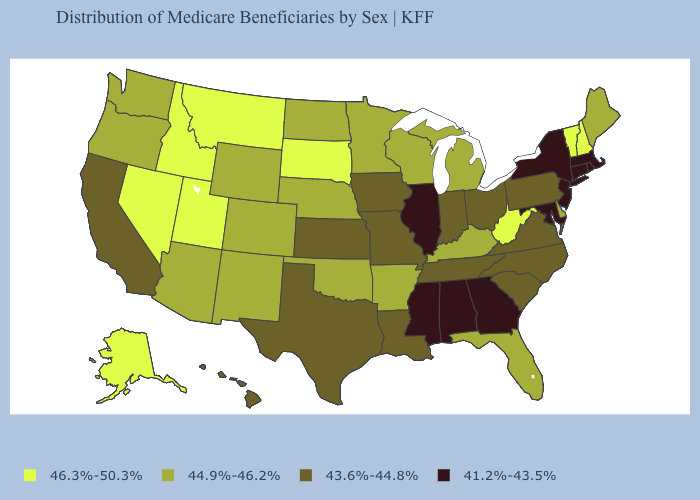What is the value of Iowa?
Write a very short answer. 43.6%-44.8%. Among the states that border Utah , which have the highest value?
Be succinct. Idaho, Nevada. What is the value of South Carolina?
Keep it brief. 43.6%-44.8%. Does Iowa have the same value as Hawaii?
Short answer required. Yes. Does Alabama have the highest value in the South?
Short answer required. No. What is the lowest value in the Northeast?
Keep it brief. 41.2%-43.5%. Name the states that have a value in the range 41.2%-43.5%?
Answer briefly. Alabama, Connecticut, Georgia, Illinois, Maryland, Massachusetts, Mississippi, New Jersey, New York, Rhode Island. Does Nevada have a higher value than Montana?
Be succinct. No. Does Virginia have a lower value than New Mexico?
Answer briefly. Yes. What is the value of Wisconsin?
Answer briefly. 44.9%-46.2%. Name the states that have a value in the range 44.9%-46.2%?
Quick response, please. Arizona, Arkansas, Colorado, Delaware, Florida, Kentucky, Maine, Michigan, Minnesota, Nebraska, New Mexico, North Dakota, Oklahoma, Oregon, Washington, Wisconsin, Wyoming. Which states have the highest value in the USA?
Quick response, please. Alaska, Idaho, Montana, Nevada, New Hampshire, South Dakota, Utah, Vermont, West Virginia. Does the map have missing data?
Give a very brief answer. No. Name the states that have a value in the range 44.9%-46.2%?
Answer briefly. Arizona, Arkansas, Colorado, Delaware, Florida, Kentucky, Maine, Michigan, Minnesota, Nebraska, New Mexico, North Dakota, Oklahoma, Oregon, Washington, Wisconsin, Wyoming. 